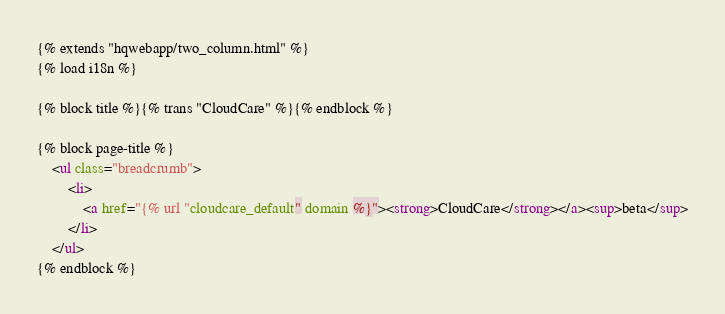<code> <loc_0><loc_0><loc_500><loc_500><_HTML_>{% extends "hqwebapp/two_column.html" %}
{% load i18n %}

{% block title %}{% trans "CloudCare" %}{% endblock %}

{% block page-title %}
    <ul class="breadcrumb">
        <li>
            <a href="{% url "cloudcare_default" domain %}"><strong>CloudCare</strong></a><sup>beta</sup>
        </li>
    </ul>
{% endblock %}
</code> 